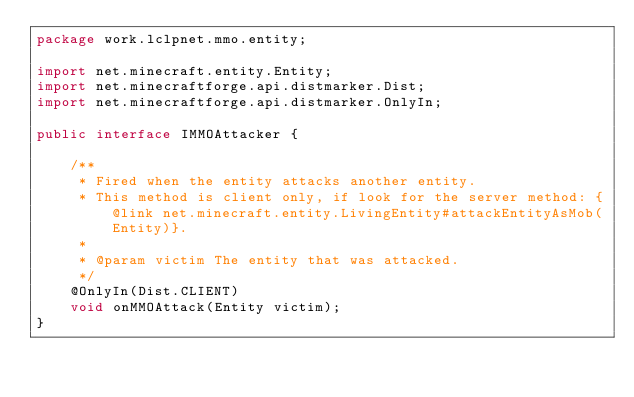Convert code to text. <code><loc_0><loc_0><loc_500><loc_500><_Java_>package work.lclpnet.mmo.entity;

import net.minecraft.entity.Entity;
import net.minecraftforge.api.distmarker.Dist;
import net.minecraftforge.api.distmarker.OnlyIn;

public interface IMMOAttacker {

    /**
     * Fired when the entity attacks another entity.
     * This method is client only, if look for the server method: {@link net.minecraft.entity.LivingEntity#attackEntityAsMob(Entity)}.
     *
     * @param victim The entity that was attacked.
     */
    @OnlyIn(Dist.CLIENT)
    void onMMOAttack(Entity victim);
}
</code> 